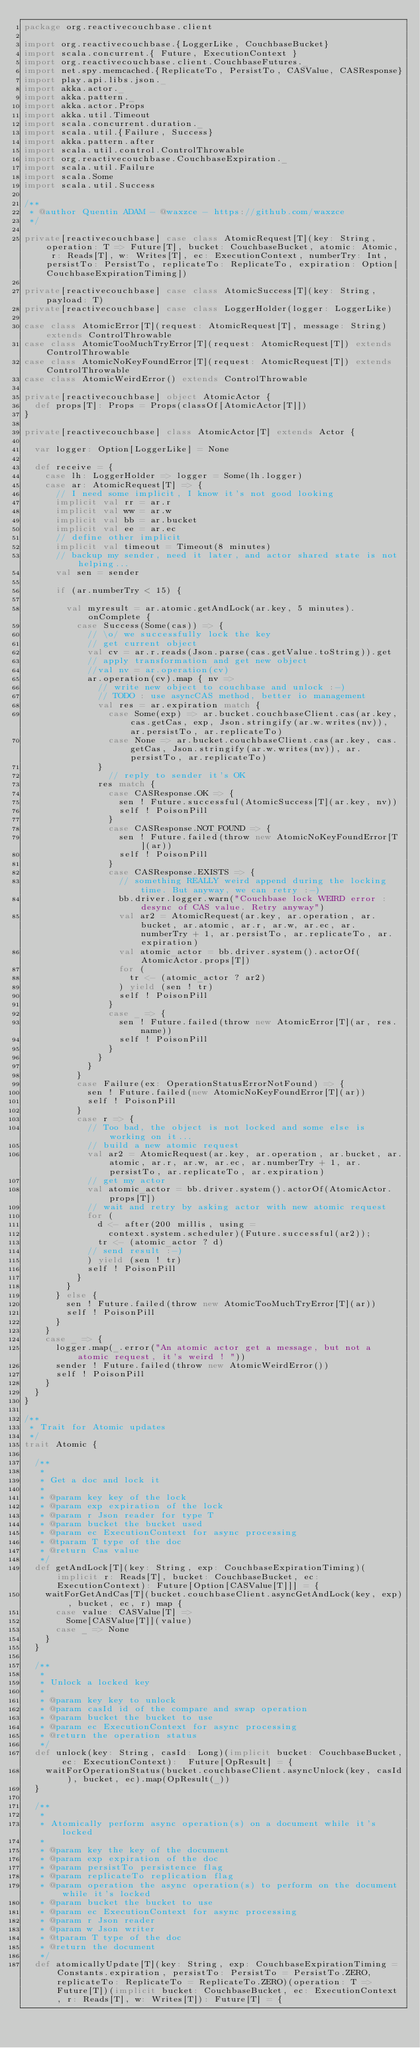<code> <loc_0><loc_0><loc_500><loc_500><_Scala_>package org.reactivecouchbase.client

import org.reactivecouchbase.{LoggerLike, CouchbaseBucket}
import scala.concurrent.{ Future, ExecutionContext }
import org.reactivecouchbase.client.CouchbaseFutures._
import net.spy.memcached.{ReplicateTo, PersistTo, CASValue, CASResponse}
import play.api.libs.json._
import akka.actor._
import akka.pattern._
import akka.actor.Props
import akka.util.Timeout
import scala.concurrent.duration._
import scala.util.{Failure, Success}
import akka.pattern.after
import scala.util.control.ControlThrowable
import org.reactivecouchbase.CouchbaseExpiration._
import scala.util.Failure
import scala.Some
import scala.util.Success

/**
 * @author Quentin ADAM - @waxzce - https://github.com/waxzce
 */

private[reactivecouchbase] case class AtomicRequest[T](key: String, operation: T => Future[T], bucket: CouchbaseBucket, atomic: Atomic, r: Reads[T], w: Writes[T], ec: ExecutionContext, numberTry: Int, persistTo: PersistTo, replicateTo: ReplicateTo, expiration: Option[CouchbaseExpirationTiming])

private[reactivecouchbase] case class AtomicSuccess[T](key: String, payload: T)
private[reactivecouchbase] case class LoggerHolder(logger: LoggerLike)

case class AtomicError[T](request: AtomicRequest[T], message: String) extends ControlThrowable
case class AtomicTooMuchTryError[T](request: AtomicRequest[T]) extends ControlThrowable
case class AtomicNoKeyFoundError[T](request: AtomicRequest[T]) extends ControlThrowable
case class AtomicWeirdError() extends ControlThrowable

private[reactivecouchbase] object AtomicActor {
  def props[T]: Props = Props(classOf[AtomicActor[T]])
}

private[reactivecouchbase] class AtomicActor[T] extends Actor {

  var logger: Option[LoggerLike] = None

  def receive = {
    case lh: LoggerHolder => logger = Some(lh.logger)
    case ar: AtomicRequest[T] => {
      // I need some implicit, I know it's not good looking
      implicit val rr = ar.r
      implicit val ww = ar.w
      implicit val bb = ar.bucket
      implicit val ee = ar.ec
      // define other implicit
      implicit val timeout = Timeout(8 minutes)
      // backup my sender, need it later, and actor shared state is not helping...
      val sen = sender

      if (ar.numberTry < 15) {

        val myresult = ar.atomic.getAndLock(ar.key, 5 minutes).onComplete {
          case Success(Some(cas)) => {
            // \o/ we successfully lock the key
            // get current object
            val cv = ar.r.reads(Json.parse(cas.getValue.toString)).get
            // apply transformation and get new object
            //val nv = ar.operation(cv)
            ar.operation(cv).map { nv =>
              // write new object to couchbase and unlock :-)
              // TODO : use asyncCAS method, better io management
              val res = ar.expiration match {
                case Some(exp) => ar.bucket.couchbaseClient.cas(ar.key, cas.getCas, exp, Json.stringify(ar.w.writes(nv)), ar.persistTo, ar.replicateTo)
                case None => ar.bucket.couchbaseClient.cas(ar.key, cas.getCas, Json.stringify(ar.w.writes(nv)), ar.persistTo, ar.replicateTo)
              }
                // reply to sender it's OK
              res match {
                case CASResponse.OK => {
                  sen ! Future.successful(AtomicSuccess[T](ar.key, nv))
                  self ! PoisonPill
                }
                case CASResponse.NOT_FOUND => {
                  sen ! Future.failed(throw new AtomicNoKeyFoundError[T](ar))
                  self ! PoisonPill
                }
                case CASResponse.EXISTS => {
                  // something REALLY weird append during the locking time. But anyway, we can retry :-)
                  bb.driver.logger.warn("Couchbase lock WEIRD error : desync of CAS value. Retry anyway")
                  val ar2 = AtomicRequest(ar.key, ar.operation, ar.bucket, ar.atomic, ar.r, ar.w, ar.ec, ar.numberTry + 1, ar.persistTo, ar.replicateTo, ar.expiration)
                  val atomic_actor = bb.driver.system().actorOf(AtomicActor.props[T])
                  for (
                    tr <- (atomic_actor ? ar2)
                  ) yield (sen ! tr)
                  self ! PoisonPill
                }
                case _ => {
                  sen ! Future.failed(throw new AtomicError[T](ar, res.name))
                  self ! PoisonPill
                }
              }
            }
          }
          case Failure(ex: OperationStatusErrorNotFound) => {
            sen ! Future.failed(new AtomicNoKeyFoundError[T](ar))
            self ! PoisonPill
          }
          case r => {
            // Too bad, the object is not locked and some else is working on it...
            // build a new atomic request
            val ar2 = AtomicRequest(ar.key, ar.operation, ar.bucket, ar.atomic, ar.r, ar.w, ar.ec, ar.numberTry + 1, ar.persistTo, ar.replicateTo, ar.expiration)
            // get my actor
            val atomic_actor = bb.driver.system().actorOf(AtomicActor.props[T])
            // wait and retry by asking actor with new atomic request
            for (
              d <- after(200 millis, using =
                context.system.scheduler)(Future.successful(ar2));
              tr <- (atomic_actor ? d)
            // send result :-)
            ) yield (sen ! tr)
            self ! PoisonPill
          }
        }
      } else {
        sen ! Future.failed(throw new AtomicTooMuchTryError[T](ar))
        self ! PoisonPill
      }
    }
    case _ => {
      logger.map(_.error("An atomic actor get a message, but not a atomic request, it's weird ! "))
      sender ! Future.failed(throw new AtomicWeirdError())
      self ! PoisonPill
    }
  }
}

/**
 * Trait for Atomic updates
 */
trait Atomic {

  /**
   *
   * Get a doc and lock it
   *
   * @param key key of the lock
   * @param exp expiration of the lock
   * @param r Json reader for type T
   * @param bucket the bucket used
   * @param ec ExecutionContext for async processing
   * @tparam T type of the doc
   * @return Cas value
   */
  def getAndLock[T](key: String, exp: CouchbaseExpirationTiming)(implicit r: Reads[T], bucket: CouchbaseBucket, ec: ExecutionContext): Future[Option[CASValue[T]]] = {
    waitForGetAndCas[T](bucket.couchbaseClient.asyncGetAndLock(key, exp), bucket, ec, r) map {
      case value: CASValue[T] =>
        Some[CASValue[T]](value)
      case _ => None
    }
  }

  /**
   *
   * Unlock a locked key
   *
   * @param key key to unlock
   * @param casId id of the compare and swap operation
   * @param bucket the bucket to use
   * @param ec ExecutionContext for async processing
   * @return the operation status
   */
  def unlock(key: String, casId: Long)(implicit bucket: CouchbaseBucket, ec: ExecutionContext):  Future[OpResult] = {
    waitForOperationStatus(bucket.couchbaseClient.asyncUnlock(key, casId), bucket, ec).map(OpResult(_))
  }

  /**
   *
   * Atomically perform async operation(s) on a document while it's locked
   *
   * @param key the key of the document
   * @param exp expiration of the doc
   * @param persistTo persistence flag
   * @param replicateTo replication flag
   * @param operation the async operation(s) to perform on the document while it's locked
   * @param bucket the bucket to use
   * @param ec ExecutionContext for async processing
   * @param r Json reader
   * @param w Json writer
   * @tparam T type of the doc
   * @return the document
   */
  def atomicallyUpdate[T](key: String, exp: CouchbaseExpirationTiming = Constants.expiration, persistTo: PersistTo = PersistTo.ZERO, replicateTo: ReplicateTo = ReplicateTo.ZERO)(operation: T => Future[T])(implicit bucket: CouchbaseBucket, ec: ExecutionContext, r: Reads[T], w: Writes[T]): Future[T] = {</code> 